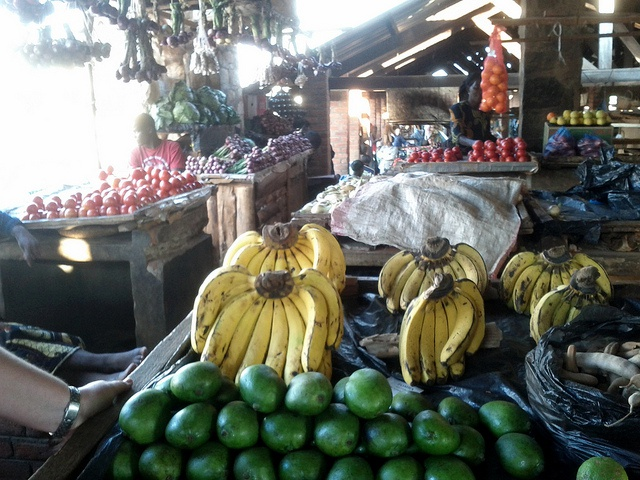Describe the objects in this image and their specific colors. I can see banana in lightblue, tan, and olive tones, banana in lightblue, olive, black, and tan tones, people in lightblue, gray, black, and darkgray tones, banana in lightblue, tan, khaki, and beige tones, and banana in lightblue, tan, gray, olive, and black tones in this image. 